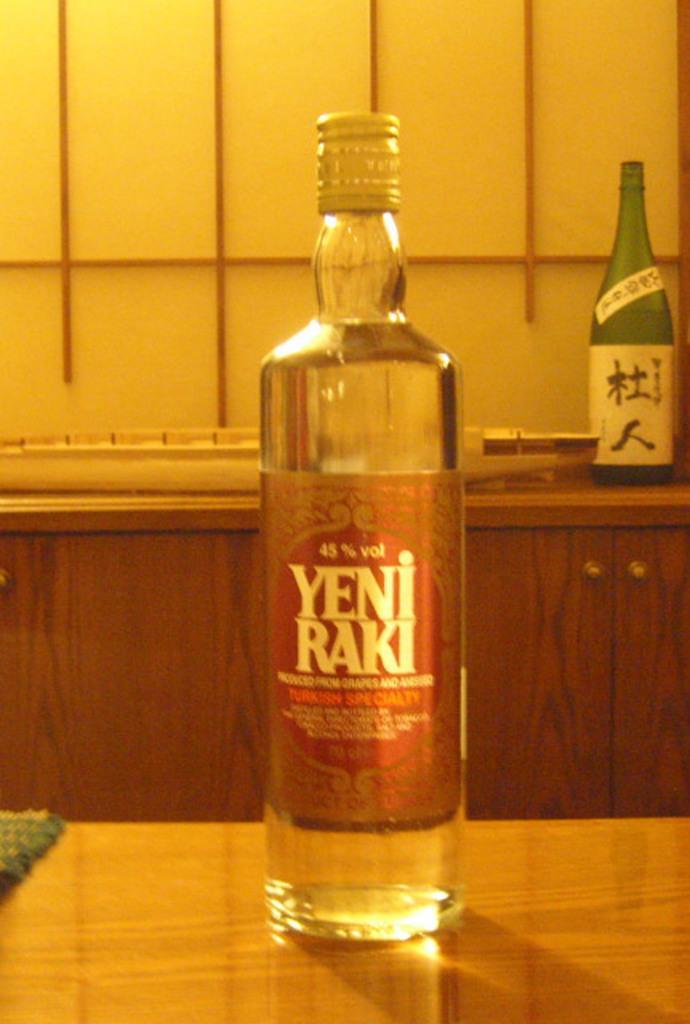In one or two sentences, can you explain what this image depicts? In this picture there is a wine bottle kept on a table and a background is another wine bottle 